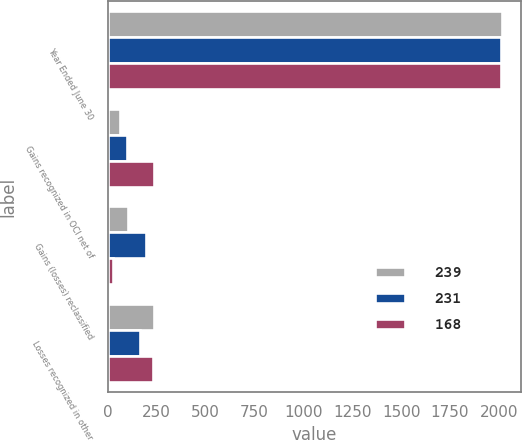Convert chart to OTSL. <chart><loc_0><loc_0><loc_500><loc_500><stacked_bar_chart><ecel><fcel>Year Ended June 30<fcel>Gains recognized in OCI net of<fcel>Gains (losses) reclassified<fcel>Losses recognized in other<nl><fcel>239<fcel>2014<fcel>63<fcel>104<fcel>239<nl><fcel>231<fcel>2013<fcel>101<fcel>195<fcel>168<nl><fcel>168<fcel>2012<fcel>236<fcel>27<fcel>231<nl></chart> 